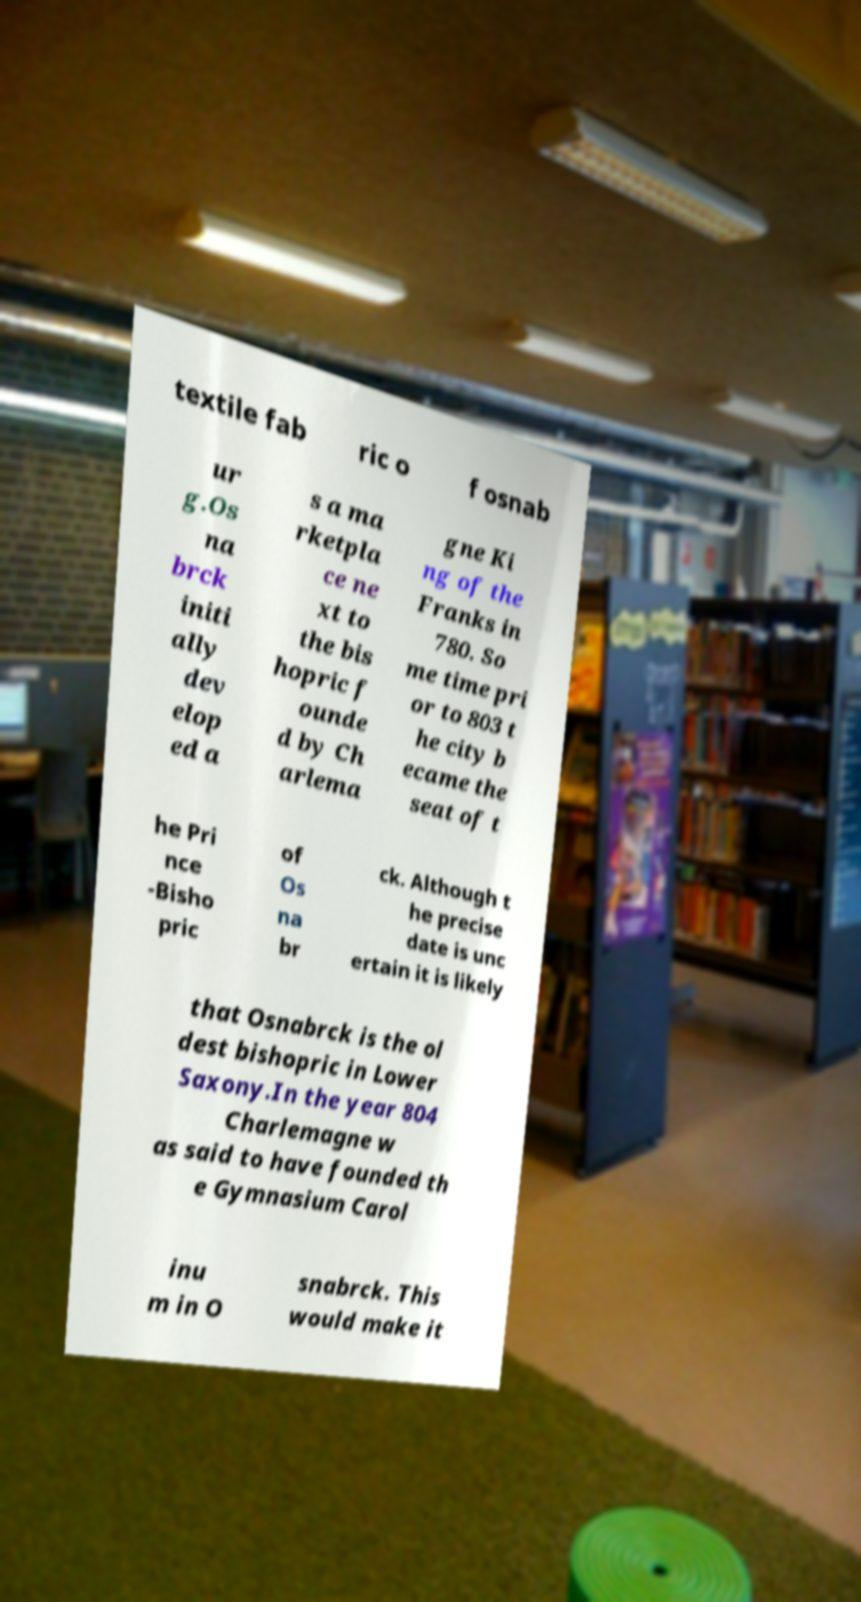Can you read and provide the text displayed in the image?This photo seems to have some interesting text. Can you extract and type it out for me? textile fab ric o f osnab ur g.Os na brck initi ally dev elop ed a s a ma rketpla ce ne xt to the bis hopric f ounde d by Ch arlema gne Ki ng of the Franks in 780. So me time pri or to 803 t he city b ecame the seat of t he Pri nce -Bisho pric of Os na br ck. Although t he precise date is unc ertain it is likely that Osnabrck is the ol dest bishopric in Lower Saxony.In the year 804 Charlemagne w as said to have founded th e Gymnasium Carol inu m in O snabrck. This would make it 